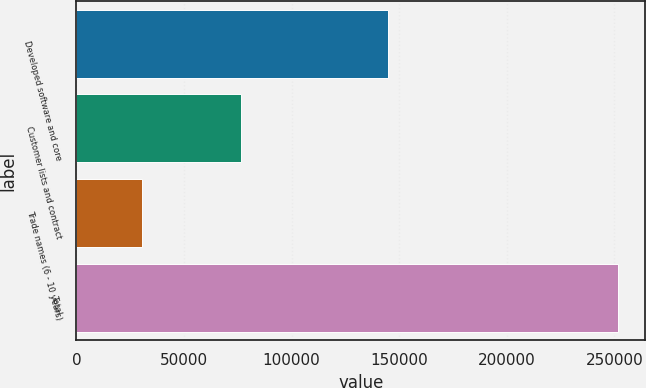Convert chart. <chart><loc_0><loc_0><loc_500><loc_500><bar_chart><fcel>Developed software and core<fcel>Customer lists and contract<fcel>Trade names (6 - 10 years)<fcel>Total<nl><fcel>144836<fcel>76630<fcel>30380<fcel>251846<nl></chart> 